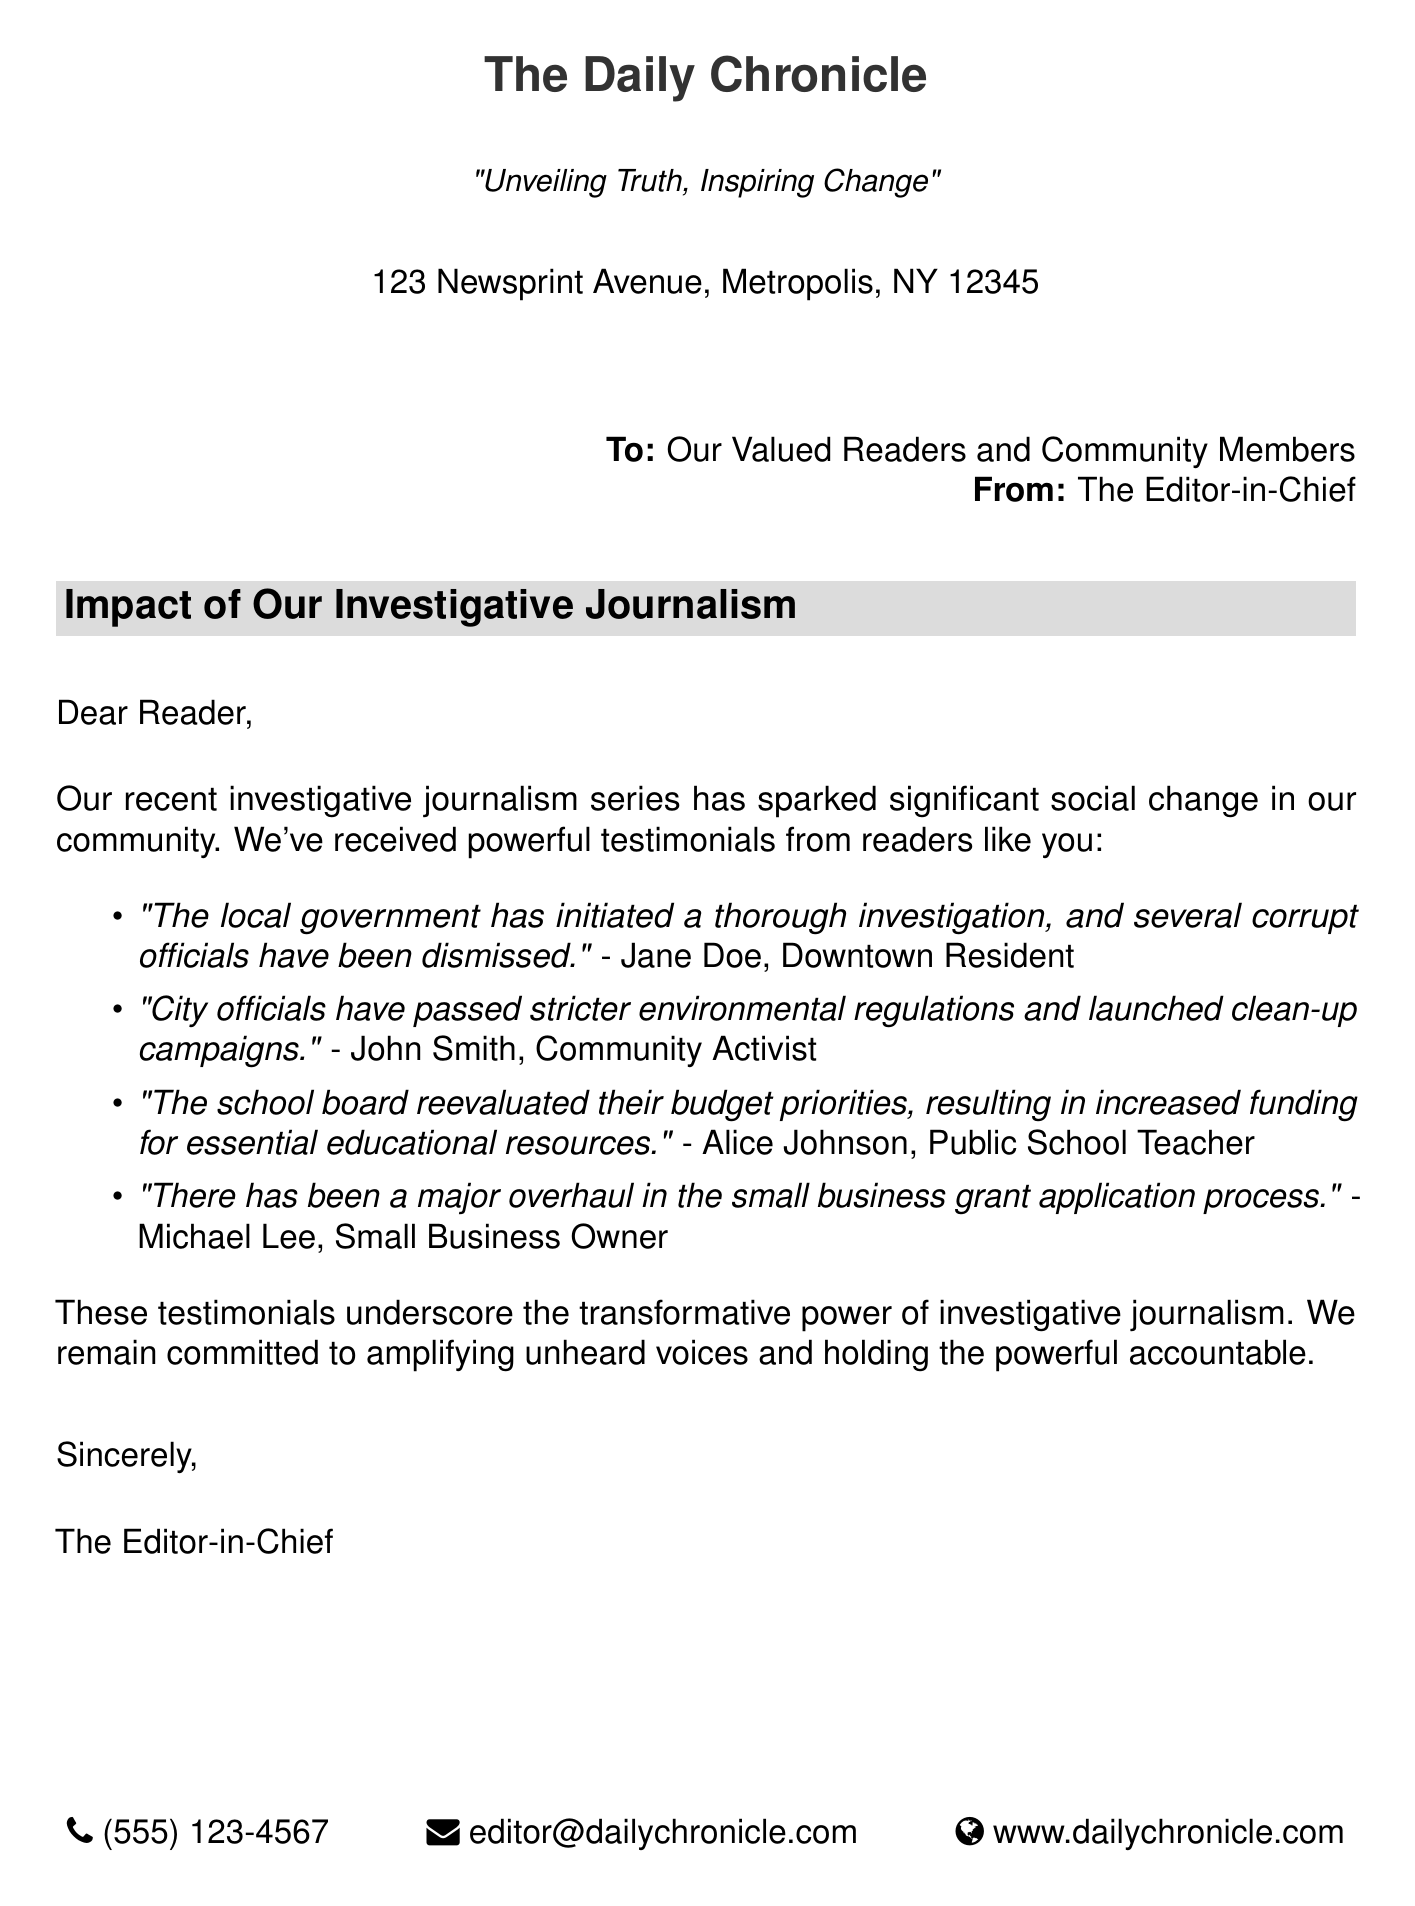what is the name of the newspaper? The name of the newspaper is mentioned in the header of the document.
Answer: The Daily Chronicle who is the letter addressed to? The letter is addressed to the readers and community members as indicated at the start of the letter.
Answer: Our Valued Readers and Community Members who is the sender of the letter? The sender of the letter is the person or title listed after "From:" in the letter.
Answer: The Editor-in-Chief how many testimonials are included in the document? The total number of testimonials listed in the document can be counted from the itemized list.
Answer: Four what positive outcome did Jane Doe reference in her testimony? Jane Doe's testimony includes a specific change initiated by local government actions.
Answer: Corrupt officials have been dismissed what action did John Smith report the city officials took? John Smith's testimony mentions a specific action taken by city officials related to regulations.
Answer: Passed stricter environmental regulations which group reevaluated their budget priorities according to Alice Johnson? Alice Johnson's testimony identifies a specific group responsible for budget evaluation.
Answer: The school board what is one change reported by Michael Lee? Michael Lee's testimony describes a particular improvement in a business-related process.
Answer: Overhaul in the small business grant application process how does the document describe the impact of investigative journalism? The document provides broad insight on the influence of investigative journalism as highlighted in the reader testimonials.
Answer: Transformative power 